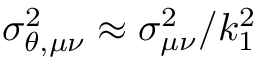<formula> <loc_0><loc_0><loc_500><loc_500>\sigma _ { \theta , \mu \nu } ^ { 2 } \approx \sigma _ { \mu \nu } ^ { 2 } / k _ { 1 } ^ { 2 }</formula> 